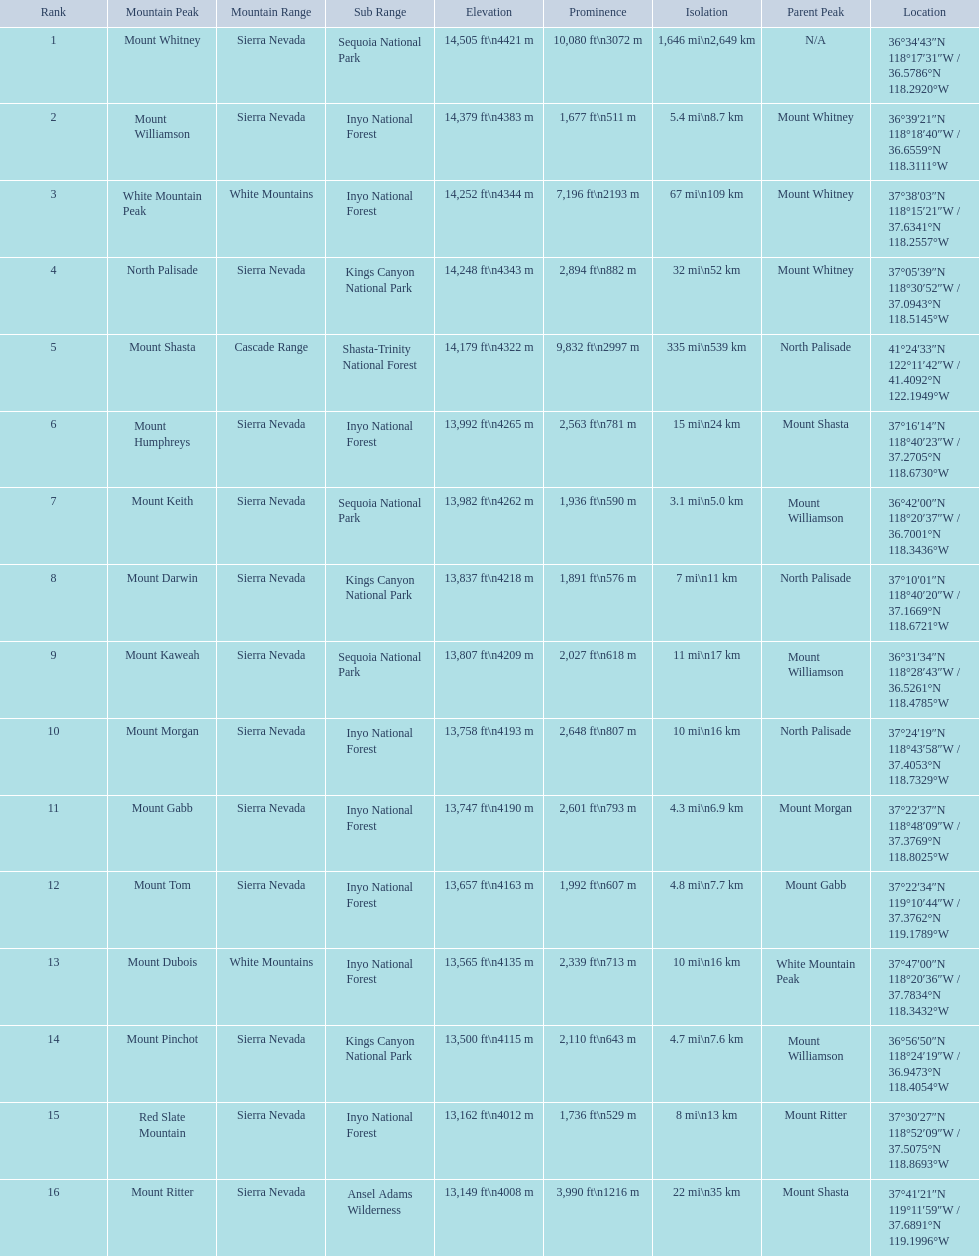What are the peaks in california? Mount Whitney, Mount Williamson, White Mountain Peak, North Palisade, Mount Shasta, Mount Humphreys, Mount Keith, Mount Darwin, Mount Kaweah, Mount Morgan, Mount Gabb, Mount Tom, Mount Dubois, Mount Pinchot, Red Slate Mountain, Mount Ritter. What are the peaks in sierra nevada, california? Mount Whitney, Mount Williamson, North Palisade, Mount Humphreys, Mount Keith, Mount Darwin, Mount Kaweah, Mount Morgan, Mount Gabb, Mount Tom, Mount Pinchot, Red Slate Mountain, Mount Ritter. What are the heights of the peaks in sierra nevada? 14,505 ft\n4421 m, 14,379 ft\n4383 m, 14,248 ft\n4343 m, 13,992 ft\n4265 m, 13,982 ft\n4262 m, 13,837 ft\n4218 m, 13,807 ft\n4209 m, 13,758 ft\n4193 m, 13,747 ft\n4190 m, 13,657 ft\n4163 m, 13,500 ft\n4115 m, 13,162 ft\n4012 m, 13,149 ft\n4008 m. Which is the highest? Mount Whitney. 